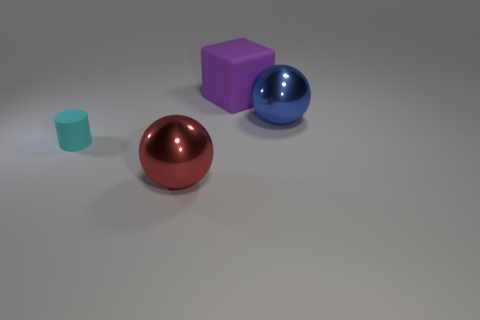There is a metallic object that is to the left of the blue metallic thing; how many large metal things are on the left side of it?
Provide a short and direct response. 0. There is a tiny rubber object; is its color the same as the metal object left of the purple matte block?
Provide a succinct answer. No. There is a cube that is the same size as the blue metal thing; what is its color?
Make the answer very short. Purple. Are there any other large metallic things that have the same shape as the red metallic thing?
Make the answer very short. Yes. Are there fewer blue rubber cylinders than red metal spheres?
Provide a short and direct response. Yes. There is a shiny ball that is to the left of the blue metallic sphere; what is its color?
Offer a very short reply. Red. There is a matte object that is left of the object in front of the small object; what shape is it?
Your answer should be compact. Cylinder. Is the material of the tiny cyan cylinder the same as the ball that is right of the red metallic thing?
Offer a very short reply. No. How many green blocks have the same size as the red thing?
Ensure brevity in your answer.  0. Are there fewer big purple cubes in front of the blue ball than large purple rubber blocks?
Provide a short and direct response. Yes. 